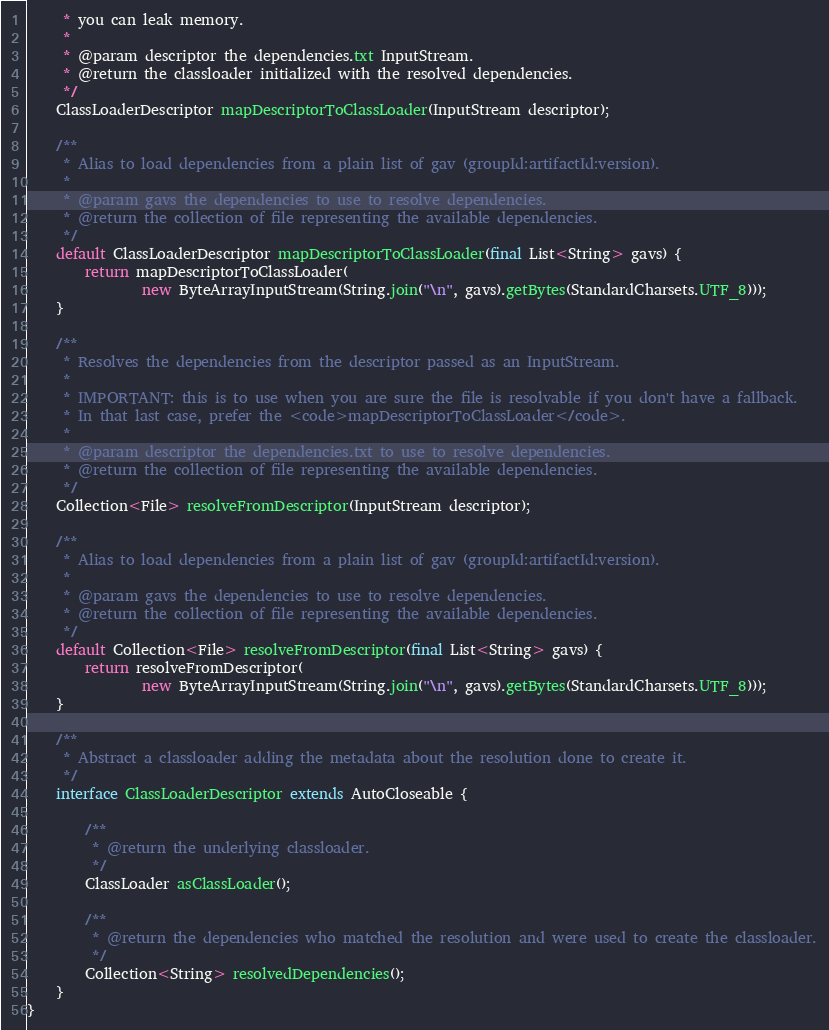<code> <loc_0><loc_0><loc_500><loc_500><_Java_>     * you can leak memory.
     *
     * @param descriptor the dependencies.txt InputStream.
     * @return the classloader initialized with the resolved dependencies.
     */
    ClassLoaderDescriptor mapDescriptorToClassLoader(InputStream descriptor);

    /**
     * Alias to load dependencies from a plain list of gav (groupId:artifactId:version).
     *
     * @param gavs the dependencies to use to resolve dependencies.
     * @return the collection of file representing the available dependencies.
     */
    default ClassLoaderDescriptor mapDescriptorToClassLoader(final List<String> gavs) {
        return mapDescriptorToClassLoader(
                new ByteArrayInputStream(String.join("\n", gavs).getBytes(StandardCharsets.UTF_8)));
    }

    /**
     * Resolves the dependencies from the descriptor passed as an InputStream.
     *
     * IMPORTANT: this is to use when you are sure the file is resolvable if you don't have a fallback.
     * In that last case, prefer the <code>mapDescriptorToClassLoader</code>.
     *
     * @param descriptor the dependencies.txt to use to resolve dependencies.
     * @return the collection of file representing the available dependencies.
     */
    Collection<File> resolveFromDescriptor(InputStream descriptor);

    /**
     * Alias to load dependencies from a plain list of gav (groupId:artifactId:version).
     *
     * @param gavs the dependencies to use to resolve dependencies.
     * @return the collection of file representing the available dependencies.
     */
    default Collection<File> resolveFromDescriptor(final List<String> gavs) {
        return resolveFromDescriptor(
                new ByteArrayInputStream(String.join("\n", gavs).getBytes(StandardCharsets.UTF_8)));
    }

    /**
     * Abstract a classloader adding the metadata about the resolution done to create it.
     */
    interface ClassLoaderDescriptor extends AutoCloseable {

        /**
         * @return the underlying classloader.
         */
        ClassLoader asClassLoader();

        /**
         * @return the dependencies who matched the resolution and were used to create the classloader.
         */
        Collection<String> resolvedDependencies();
    }
}
</code> 